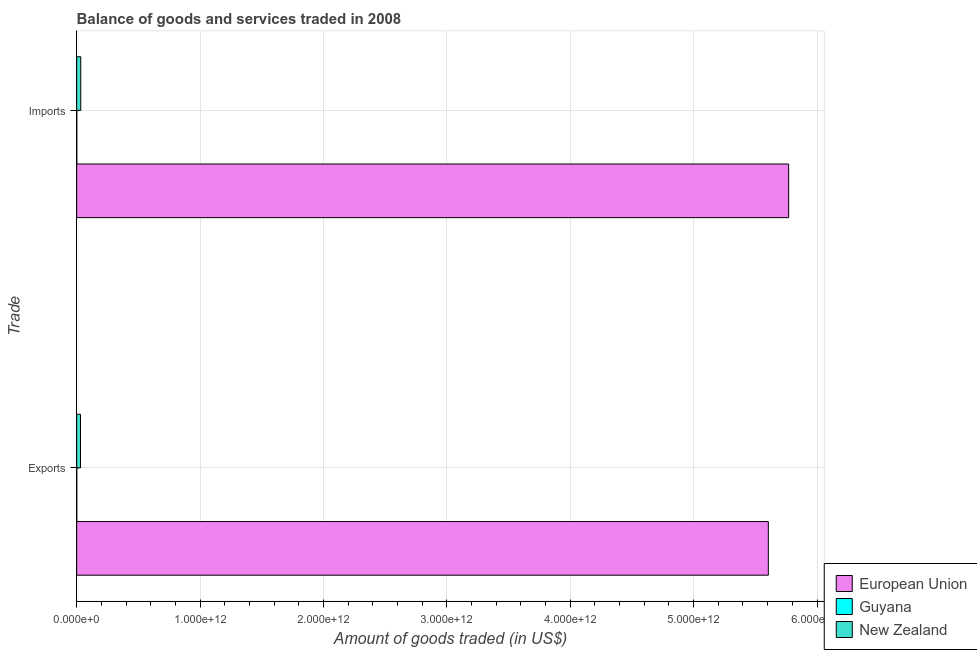Are the number of bars per tick equal to the number of legend labels?
Offer a terse response. Yes. Are the number of bars on each tick of the Y-axis equal?
Provide a short and direct response. Yes. What is the label of the 1st group of bars from the top?
Your answer should be very brief. Imports. What is the amount of goods imported in European Union?
Provide a succinct answer. 5.77e+12. Across all countries, what is the maximum amount of goods exported?
Give a very brief answer. 5.61e+12. Across all countries, what is the minimum amount of goods imported?
Keep it short and to the point. 1.32e+09. In which country was the amount of goods exported minimum?
Your answer should be very brief. Guyana. What is the total amount of goods exported in the graph?
Your response must be concise. 5.64e+12. What is the difference between the amount of goods exported in European Union and that in New Zealand?
Provide a short and direct response. 5.57e+12. What is the difference between the amount of goods exported in European Union and the amount of goods imported in Guyana?
Offer a terse response. 5.60e+12. What is the average amount of goods exported per country?
Your answer should be compact. 1.88e+12. What is the difference between the amount of goods imported and amount of goods exported in Guyana?
Make the answer very short. 5.22e+08. In how many countries, is the amount of goods imported greater than 4400000000000 US$?
Keep it short and to the point. 1. What is the ratio of the amount of goods imported in Guyana to that in New Zealand?
Offer a terse response. 0.04. Is the amount of goods exported in New Zealand less than that in European Union?
Give a very brief answer. Yes. In how many countries, is the amount of goods imported greater than the average amount of goods imported taken over all countries?
Provide a succinct answer. 1. What does the 1st bar from the top in Exports represents?
Your answer should be compact. New Zealand. Are all the bars in the graph horizontal?
Provide a short and direct response. Yes. How many countries are there in the graph?
Provide a short and direct response. 3. What is the difference between two consecutive major ticks on the X-axis?
Make the answer very short. 1.00e+12. Does the graph contain grids?
Your answer should be very brief. Yes. How are the legend labels stacked?
Make the answer very short. Vertical. What is the title of the graph?
Ensure brevity in your answer.  Balance of goods and services traded in 2008. Does "Guam" appear as one of the legend labels in the graph?
Give a very brief answer. No. What is the label or title of the X-axis?
Your answer should be compact. Amount of goods traded (in US$). What is the label or title of the Y-axis?
Offer a terse response. Trade. What is the Amount of goods traded (in US$) in European Union in Exports?
Ensure brevity in your answer.  5.61e+12. What is the Amount of goods traded (in US$) of Guyana in Exports?
Your answer should be compact. 8.02e+08. What is the Amount of goods traded (in US$) of New Zealand in Exports?
Your response must be concise. 3.11e+1. What is the Amount of goods traded (in US$) of European Union in Imports?
Make the answer very short. 5.77e+12. What is the Amount of goods traded (in US$) in Guyana in Imports?
Your answer should be very brief. 1.32e+09. What is the Amount of goods traded (in US$) in New Zealand in Imports?
Your answer should be compact. 3.32e+1. Across all Trade, what is the maximum Amount of goods traded (in US$) in European Union?
Ensure brevity in your answer.  5.77e+12. Across all Trade, what is the maximum Amount of goods traded (in US$) of Guyana?
Offer a very short reply. 1.32e+09. Across all Trade, what is the maximum Amount of goods traded (in US$) in New Zealand?
Offer a very short reply. 3.32e+1. Across all Trade, what is the minimum Amount of goods traded (in US$) in European Union?
Ensure brevity in your answer.  5.61e+12. Across all Trade, what is the minimum Amount of goods traded (in US$) of Guyana?
Provide a succinct answer. 8.02e+08. Across all Trade, what is the minimum Amount of goods traded (in US$) in New Zealand?
Keep it short and to the point. 3.11e+1. What is the total Amount of goods traded (in US$) in European Union in the graph?
Offer a terse response. 1.14e+13. What is the total Amount of goods traded (in US$) of Guyana in the graph?
Offer a very short reply. 2.13e+09. What is the total Amount of goods traded (in US$) of New Zealand in the graph?
Provide a short and direct response. 6.43e+1. What is the difference between the Amount of goods traded (in US$) in European Union in Exports and that in Imports?
Provide a short and direct response. -1.65e+11. What is the difference between the Amount of goods traded (in US$) of Guyana in Exports and that in Imports?
Offer a terse response. -5.22e+08. What is the difference between the Amount of goods traded (in US$) in New Zealand in Exports and that in Imports?
Your answer should be compact. -2.14e+09. What is the difference between the Amount of goods traded (in US$) of European Union in Exports and the Amount of goods traded (in US$) of Guyana in Imports?
Your answer should be compact. 5.60e+12. What is the difference between the Amount of goods traded (in US$) in European Union in Exports and the Amount of goods traded (in US$) in New Zealand in Imports?
Your answer should be compact. 5.57e+12. What is the difference between the Amount of goods traded (in US$) of Guyana in Exports and the Amount of goods traded (in US$) of New Zealand in Imports?
Offer a very short reply. -3.24e+1. What is the average Amount of goods traded (in US$) in European Union per Trade?
Provide a short and direct response. 5.69e+12. What is the average Amount of goods traded (in US$) of Guyana per Trade?
Offer a terse response. 1.06e+09. What is the average Amount of goods traded (in US$) of New Zealand per Trade?
Your response must be concise. 3.22e+1. What is the difference between the Amount of goods traded (in US$) in European Union and Amount of goods traded (in US$) in Guyana in Exports?
Your answer should be compact. 5.60e+12. What is the difference between the Amount of goods traded (in US$) of European Union and Amount of goods traded (in US$) of New Zealand in Exports?
Offer a terse response. 5.57e+12. What is the difference between the Amount of goods traded (in US$) of Guyana and Amount of goods traded (in US$) of New Zealand in Exports?
Offer a terse response. -3.03e+1. What is the difference between the Amount of goods traded (in US$) in European Union and Amount of goods traded (in US$) in Guyana in Imports?
Give a very brief answer. 5.77e+12. What is the difference between the Amount of goods traded (in US$) of European Union and Amount of goods traded (in US$) of New Zealand in Imports?
Ensure brevity in your answer.  5.74e+12. What is the difference between the Amount of goods traded (in US$) in Guyana and Amount of goods traded (in US$) in New Zealand in Imports?
Provide a succinct answer. -3.19e+1. What is the ratio of the Amount of goods traded (in US$) of European Union in Exports to that in Imports?
Ensure brevity in your answer.  0.97. What is the ratio of the Amount of goods traded (in US$) of Guyana in Exports to that in Imports?
Ensure brevity in your answer.  0.61. What is the ratio of the Amount of goods traded (in US$) in New Zealand in Exports to that in Imports?
Your answer should be compact. 0.94. What is the difference between the highest and the second highest Amount of goods traded (in US$) in European Union?
Keep it short and to the point. 1.65e+11. What is the difference between the highest and the second highest Amount of goods traded (in US$) of Guyana?
Your answer should be compact. 5.22e+08. What is the difference between the highest and the second highest Amount of goods traded (in US$) in New Zealand?
Provide a short and direct response. 2.14e+09. What is the difference between the highest and the lowest Amount of goods traded (in US$) in European Union?
Provide a short and direct response. 1.65e+11. What is the difference between the highest and the lowest Amount of goods traded (in US$) of Guyana?
Your response must be concise. 5.22e+08. What is the difference between the highest and the lowest Amount of goods traded (in US$) in New Zealand?
Your response must be concise. 2.14e+09. 